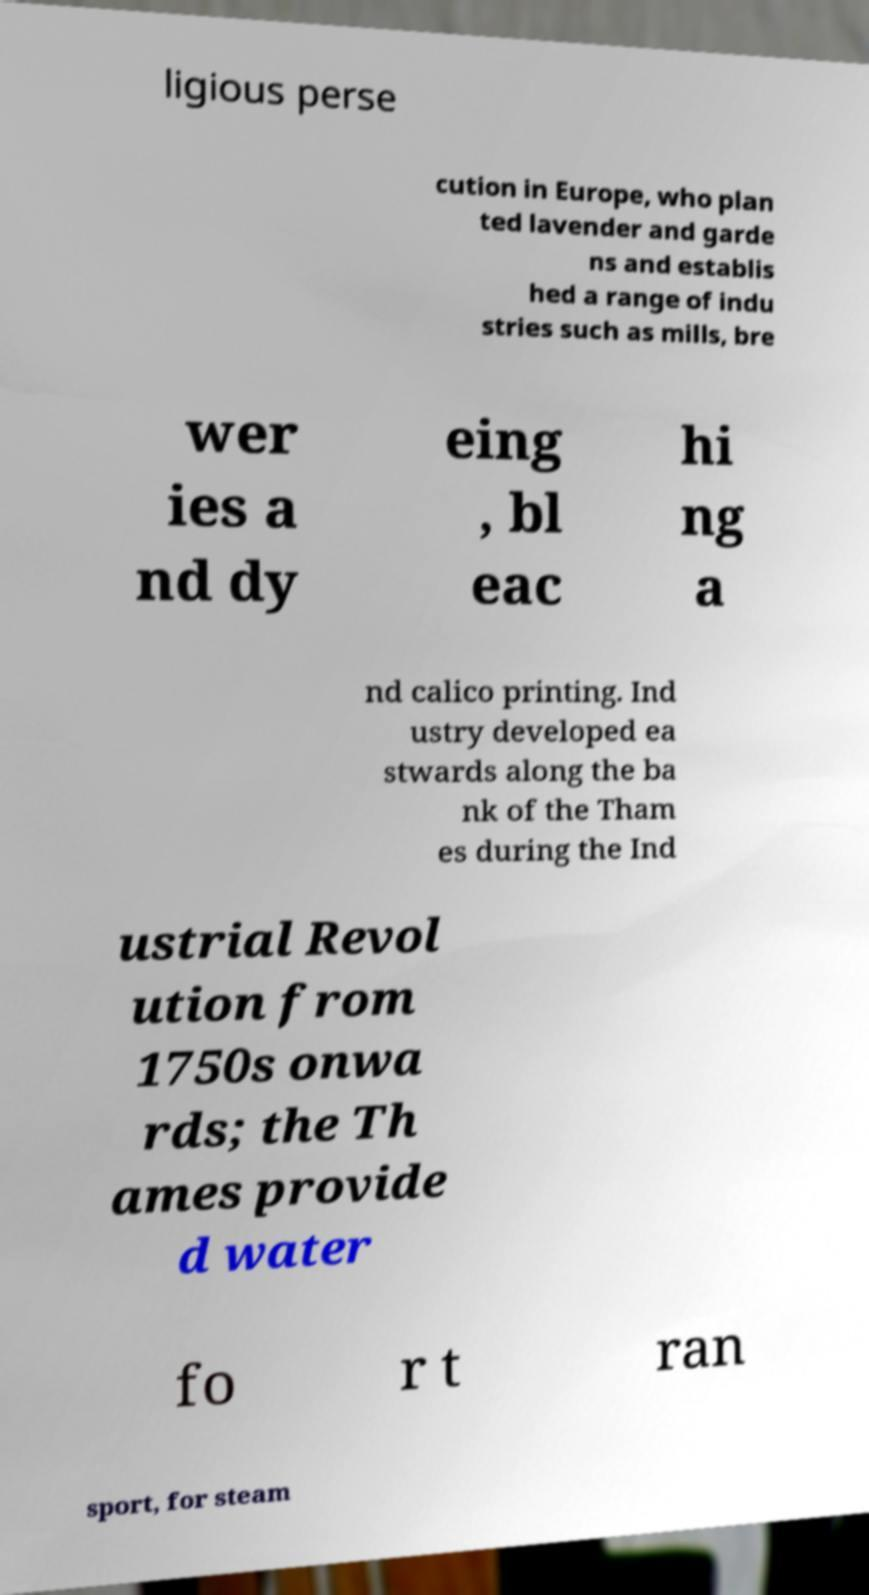Can you read and provide the text displayed in the image?This photo seems to have some interesting text. Can you extract and type it out for me? ligious perse cution in Europe, who plan ted lavender and garde ns and establis hed a range of indu stries such as mills, bre wer ies a nd dy eing , bl eac hi ng a nd calico printing. Ind ustry developed ea stwards along the ba nk of the Tham es during the Ind ustrial Revol ution from 1750s onwa rds; the Th ames provide d water fo r t ran sport, for steam 